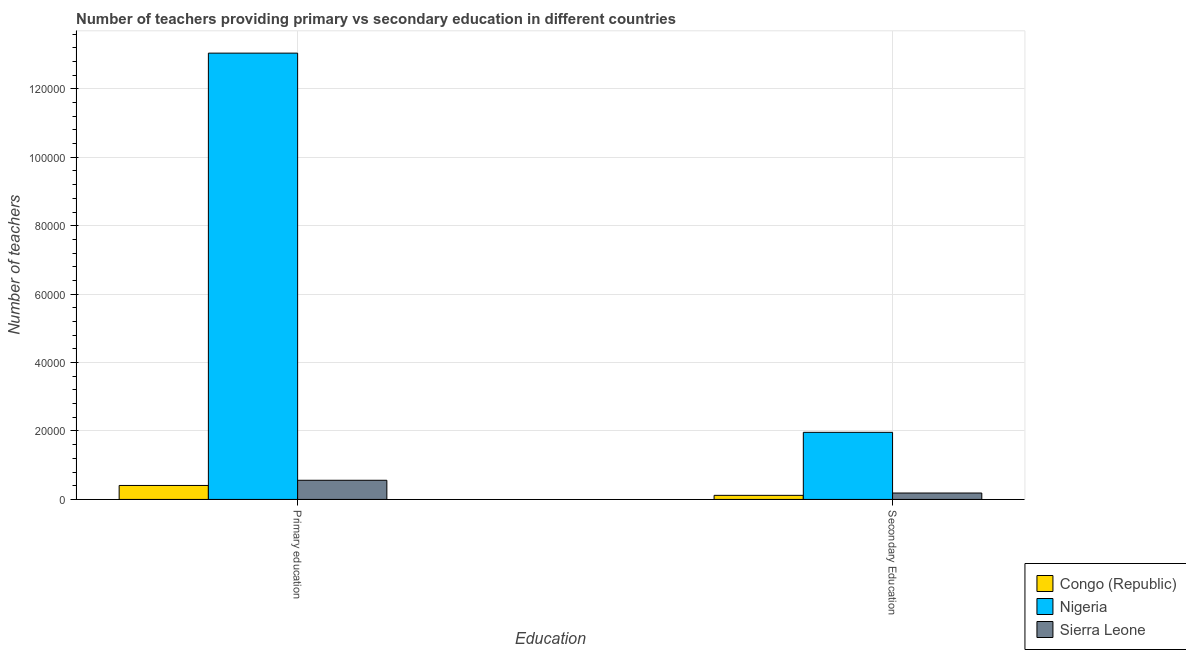How many different coloured bars are there?
Provide a short and direct response. 3. Are the number of bars on each tick of the X-axis equal?
Your answer should be very brief. Yes. What is the number of primary teachers in Nigeria?
Give a very brief answer. 1.30e+05. Across all countries, what is the maximum number of secondary teachers?
Your response must be concise. 1.96e+04. Across all countries, what is the minimum number of secondary teachers?
Provide a short and direct response. 1191. In which country was the number of primary teachers maximum?
Offer a terse response. Nigeria. In which country was the number of primary teachers minimum?
Provide a short and direct response. Congo (Republic). What is the total number of primary teachers in the graph?
Offer a very short reply. 1.40e+05. What is the difference between the number of primary teachers in Nigeria and that in Sierra Leone?
Ensure brevity in your answer.  1.25e+05. What is the difference between the number of secondary teachers in Congo (Republic) and the number of primary teachers in Nigeria?
Offer a terse response. -1.29e+05. What is the average number of primary teachers per country?
Keep it short and to the point. 4.67e+04. What is the difference between the number of primary teachers and number of secondary teachers in Sierra Leone?
Your answer should be very brief. 3728. In how many countries, is the number of primary teachers greater than 104000 ?
Your response must be concise. 1. What is the ratio of the number of primary teachers in Sierra Leone to that in Nigeria?
Offer a very short reply. 0.04. Is the number of secondary teachers in Nigeria less than that in Congo (Republic)?
Keep it short and to the point. No. In how many countries, is the number of primary teachers greater than the average number of primary teachers taken over all countries?
Make the answer very short. 1. What does the 2nd bar from the left in Primary education represents?
Offer a very short reply. Nigeria. What does the 1st bar from the right in Secondary Education represents?
Give a very brief answer. Sierra Leone. How many bars are there?
Your answer should be very brief. 6. What is the difference between two consecutive major ticks on the Y-axis?
Ensure brevity in your answer.  2.00e+04. Are the values on the major ticks of Y-axis written in scientific E-notation?
Ensure brevity in your answer.  No. Does the graph contain any zero values?
Offer a terse response. No. How many legend labels are there?
Provide a succinct answer. 3. What is the title of the graph?
Offer a terse response. Number of teachers providing primary vs secondary education in different countries. What is the label or title of the X-axis?
Offer a very short reply. Education. What is the label or title of the Y-axis?
Provide a succinct answer. Number of teachers. What is the Number of teachers in Congo (Republic) in Primary education?
Make the answer very short. 4083. What is the Number of teachers of Nigeria in Primary education?
Your answer should be very brief. 1.30e+05. What is the Number of teachers of Sierra Leone in Primary education?
Your answer should be very brief. 5599. What is the Number of teachers in Congo (Republic) in Secondary Education?
Give a very brief answer. 1191. What is the Number of teachers of Nigeria in Secondary Education?
Make the answer very short. 1.96e+04. What is the Number of teachers in Sierra Leone in Secondary Education?
Make the answer very short. 1871. Across all Education, what is the maximum Number of teachers of Congo (Republic)?
Provide a short and direct response. 4083. Across all Education, what is the maximum Number of teachers of Nigeria?
Your answer should be compact. 1.30e+05. Across all Education, what is the maximum Number of teachers of Sierra Leone?
Your answer should be very brief. 5599. Across all Education, what is the minimum Number of teachers of Congo (Republic)?
Keep it short and to the point. 1191. Across all Education, what is the minimum Number of teachers of Nigeria?
Offer a very short reply. 1.96e+04. Across all Education, what is the minimum Number of teachers of Sierra Leone?
Offer a terse response. 1871. What is the total Number of teachers of Congo (Republic) in the graph?
Offer a terse response. 5274. What is the total Number of teachers of Nigeria in the graph?
Your answer should be compact. 1.50e+05. What is the total Number of teachers of Sierra Leone in the graph?
Make the answer very short. 7470. What is the difference between the Number of teachers in Congo (Republic) in Primary education and that in Secondary Education?
Your answer should be compact. 2892. What is the difference between the Number of teachers in Nigeria in Primary education and that in Secondary Education?
Your response must be concise. 1.11e+05. What is the difference between the Number of teachers in Sierra Leone in Primary education and that in Secondary Education?
Provide a succinct answer. 3728. What is the difference between the Number of teachers in Congo (Republic) in Primary education and the Number of teachers in Nigeria in Secondary Education?
Offer a terse response. -1.55e+04. What is the difference between the Number of teachers in Congo (Republic) in Primary education and the Number of teachers in Sierra Leone in Secondary Education?
Your answer should be compact. 2212. What is the difference between the Number of teachers in Nigeria in Primary education and the Number of teachers in Sierra Leone in Secondary Education?
Your answer should be very brief. 1.29e+05. What is the average Number of teachers in Congo (Republic) per Education?
Your answer should be very brief. 2637. What is the average Number of teachers in Nigeria per Education?
Ensure brevity in your answer.  7.50e+04. What is the average Number of teachers in Sierra Leone per Education?
Offer a terse response. 3735. What is the difference between the Number of teachers of Congo (Republic) and Number of teachers of Nigeria in Primary education?
Keep it short and to the point. -1.26e+05. What is the difference between the Number of teachers in Congo (Republic) and Number of teachers in Sierra Leone in Primary education?
Offer a very short reply. -1516. What is the difference between the Number of teachers in Nigeria and Number of teachers in Sierra Leone in Primary education?
Your answer should be compact. 1.25e+05. What is the difference between the Number of teachers in Congo (Republic) and Number of teachers in Nigeria in Secondary Education?
Your answer should be very brief. -1.84e+04. What is the difference between the Number of teachers in Congo (Republic) and Number of teachers in Sierra Leone in Secondary Education?
Ensure brevity in your answer.  -680. What is the difference between the Number of teachers in Nigeria and Number of teachers in Sierra Leone in Secondary Education?
Provide a short and direct response. 1.77e+04. What is the ratio of the Number of teachers of Congo (Republic) in Primary education to that in Secondary Education?
Offer a terse response. 3.43. What is the ratio of the Number of teachers in Nigeria in Primary education to that in Secondary Education?
Your answer should be compact. 6.65. What is the ratio of the Number of teachers of Sierra Leone in Primary education to that in Secondary Education?
Make the answer very short. 2.99. What is the difference between the highest and the second highest Number of teachers in Congo (Republic)?
Offer a terse response. 2892. What is the difference between the highest and the second highest Number of teachers of Nigeria?
Make the answer very short. 1.11e+05. What is the difference between the highest and the second highest Number of teachers of Sierra Leone?
Your response must be concise. 3728. What is the difference between the highest and the lowest Number of teachers in Congo (Republic)?
Provide a short and direct response. 2892. What is the difference between the highest and the lowest Number of teachers in Nigeria?
Your answer should be compact. 1.11e+05. What is the difference between the highest and the lowest Number of teachers of Sierra Leone?
Give a very brief answer. 3728. 